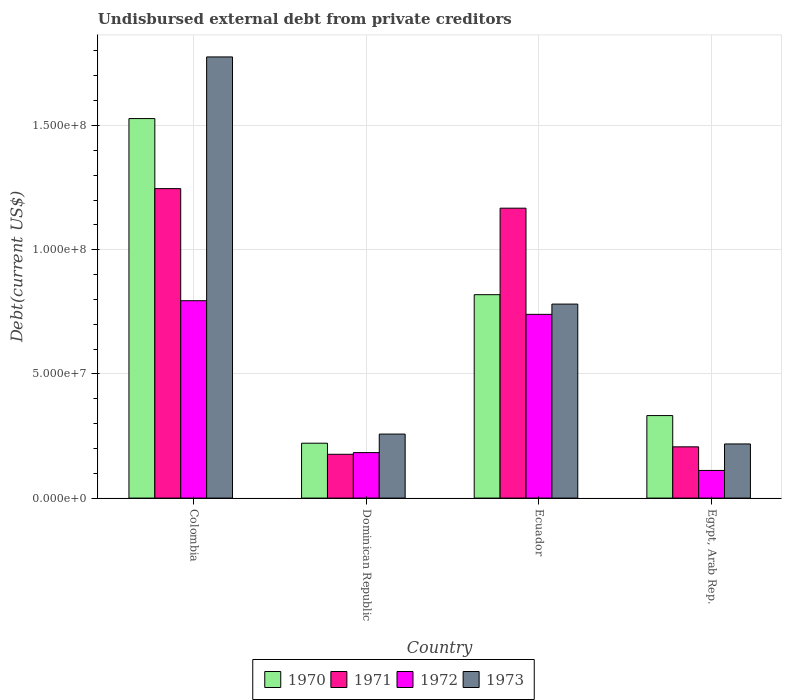How many different coloured bars are there?
Make the answer very short. 4. Are the number of bars per tick equal to the number of legend labels?
Provide a short and direct response. Yes. What is the label of the 3rd group of bars from the left?
Provide a short and direct response. Ecuador. In how many cases, is the number of bars for a given country not equal to the number of legend labels?
Give a very brief answer. 0. What is the total debt in 1970 in Ecuador?
Offer a terse response. 8.19e+07. Across all countries, what is the maximum total debt in 1970?
Provide a short and direct response. 1.53e+08. Across all countries, what is the minimum total debt in 1971?
Ensure brevity in your answer.  1.76e+07. In which country was the total debt in 1971 minimum?
Your response must be concise. Dominican Republic. What is the total total debt in 1971 in the graph?
Keep it short and to the point. 2.80e+08. What is the difference between the total debt in 1971 in Colombia and that in Dominican Republic?
Your answer should be compact. 1.07e+08. What is the difference between the total debt in 1973 in Dominican Republic and the total debt in 1972 in Ecuador?
Provide a short and direct response. -4.82e+07. What is the average total debt in 1972 per country?
Make the answer very short. 4.57e+07. What is the difference between the total debt of/in 1972 and total debt of/in 1970 in Ecuador?
Keep it short and to the point. -7.92e+06. In how many countries, is the total debt in 1973 greater than 20000000 US$?
Offer a terse response. 4. What is the ratio of the total debt in 1972 in Colombia to that in Dominican Republic?
Ensure brevity in your answer.  4.34. What is the difference between the highest and the second highest total debt in 1973?
Offer a very short reply. 9.95e+07. What is the difference between the highest and the lowest total debt in 1972?
Provide a succinct answer. 6.83e+07. What does the 2nd bar from the right in Egypt, Arab Rep. represents?
Offer a terse response. 1972. How many bars are there?
Provide a short and direct response. 16. How many countries are there in the graph?
Give a very brief answer. 4. What is the difference between two consecutive major ticks on the Y-axis?
Offer a terse response. 5.00e+07. Are the values on the major ticks of Y-axis written in scientific E-notation?
Keep it short and to the point. Yes. Where does the legend appear in the graph?
Offer a very short reply. Bottom center. How many legend labels are there?
Keep it short and to the point. 4. What is the title of the graph?
Your answer should be compact. Undisbursed external debt from private creditors. Does "1983" appear as one of the legend labels in the graph?
Provide a short and direct response. No. What is the label or title of the X-axis?
Offer a terse response. Country. What is the label or title of the Y-axis?
Your answer should be compact. Debt(current US$). What is the Debt(current US$) in 1970 in Colombia?
Offer a terse response. 1.53e+08. What is the Debt(current US$) of 1971 in Colombia?
Make the answer very short. 1.25e+08. What is the Debt(current US$) of 1972 in Colombia?
Your answer should be very brief. 7.95e+07. What is the Debt(current US$) of 1973 in Colombia?
Keep it short and to the point. 1.78e+08. What is the Debt(current US$) of 1970 in Dominican Republic?
Provide a succinct answer. 2.21e+07. What is the Debt(current US$) of 1971 in Dominican Republic?
Offer a very short reply. 1.76e+07. What is the Debt(current US$) in 1972 in Dominican Republic?
Your answer should be very brief. 1.83e+07. What is the Debt(current US$) of 1973 in Dominican Republic?
Your answer should be very brief. 2.58e+07. What is the Debt(current US$) in 1970 in Ecuador?
Provide a short and direct response. 8.19e+07. What is the Debt(current US$) in 1971 in Ecuador?
Keep it short and to the point. 1.17e+08. What is the Debt(current US$) of 1972 in Ecuador?
Provide a succinct answer. 7.40e+07. What is the Debt(current US$) of 1973 in Ecuador?
Provide a succinct answer. 7.81e+07. What is the Debt(current US$) in 1970 in Egypt, Arab Rep.?
Offer a terse response. 3.32e+07. What is the Debt(current US$) in 1971 in Egypt, Arab Rep.?
Your answer should be compact. 2.06e+07. What is the Debt(current US$) of 1972 in Egypt, Arab Rep.?
Your answer should be compact. 1.11e+07. What is the Debt(current US$) in 1973 in Egypt, Arab Rep.?
Ensure brevity in your answer.  2.18e+07. Across all countries, what is the maximum Debt(current US$) in 1970?
Offer a very short reply. 1.53e+08. Across all countries, what is the maximum Debt(current US$) in 1971?
Your response must be concise. 1.25e+08. Across all countries, what is the maximum Debt(current US$) of 1972?
Offer a terse response. 7.95e+07. Across all countries, what is the maximum Debt(current US$) of 1973?
Give a very brief answer. 1.78e+08. Across all countries, what is the minimum Debt(current US$) in 1970?
Your answer should be very brief. 2.21e+07. Across all countries, what is the minimum Debt(current US$) in 1971?
Your answer should be compact. 1.76e+07. Across all countries, what is the minimum Debt(current US$) in 1972?
Your response must be concise. 1.11e+07. Across all countries, what is the minimum Debt(current US$) in 1973?
Provide a succinct answer. 2.18e+07. What is the total Debt(current US$) of 1970 in the graph?
Your answer should be compact. 2.90e+08. What is the total Debt(current US$) in 1971 in the graph?
Ensure brevity in your answer.  2.80e+08. What is the total Debt(current US$) of 1972 in the graph?
Offer a terse response. 1.83e+08. What is the total Debt(current US$) in 1973 in the graph?
Your response must be concise. 3.03e+08. What is the difference between the Debt(current US$) in 1970 in Colombia and that in Dominican Republic?
Provide a succinct answer. 1.31e+08. What is the difference between the Debt(current US$) in 1971 in Colombia and that in Dominican Republic?
Offer a terse response. 1.07e+08. What is the difference between the Debt(current US$) of 1972 in Colombia and that in Dominican Republic?
Keep it short and to the point. 6.12e+07. What is the difference between the Debt(current US$) of 1973 in Colombia and that in Dominican Republic?
Ensure brevity in your answer.  1.52e+08. What is the difference between the Debt(current US$) in 1970 in Colombia and that in Ecuador?
Provide a short and direct response. 7.09e+07. What is the difference between the Debt(current US$) in 1971 in Colombia and that in Ecuador?
Provide a succinct answer. 7.88e+06. What is the difference between the Debt(current US$) in 1972 in Colombia and that in Ecuador?
Make the answer very short. 5.49e+06. What is the difference between the Debt(current US$) in 1973 in Colombia and that in Ecuador?
Your answer should be compact. 9.95e+07. What is the difference between the Debt(current US$) in 1970 in Colombia and that in Egypt, Arab Rep.?
Keep it short and to the point. 1.20e+08. What is the difference between the Debt(current US$) in 1971 in Colombia and that in Egypt, Arab Rep.?
Ensure brevity in your answer.  1.04e+08. What is the difference between the Debt(current US$) in 1972 in Colombia and that in Egypt, Arab Rep.?
Ensure brevity in your answer.  6.83e+07. What is the difference between the Debt(current US$) in 1973 in Colombia and that in Egypt, Arab Rep.?
Your response must be concise. 1.56e+08. What is the difference between the Debt(current US$) of 1970 in Dominican Republic and that in Ecuador?
Offer a very short reply. -5.98e+07. What is the difference between the Debt(current US$) of 1971 in Dominican Republic and that in Ecuador?
Keep it short and to the point. -9.91e+07. What is the difference between the Debt(current US$) of 1972 in Dominican Republic and that in Ecuador?
Keep it short and to the point. -5.57e+07. What is the difference between the Debt(current US$) of 1973 in Dominican Republic and that in Ecuador?
Offer a terse response. -5.23e+07. What is the difference between the Debt(current US$) of 1970 in Dominican Republic and that in Egypt, Arab Rep.?
Your answer should be compact. -1.11e+07. What is the difference between the Debt(current US$) in 1971 in Dominican Republic and that in Egypt, Arab Rep.?
Provide a succinct answer. -3.00e+06. What is the difference between the Debt(current US$) in 1972 in Dominican Republic and that in Egypt, Arab Rep.?
Ensure brevity in your answer.  7.19e+06. What is the difference between the Debt(current US$) of 1973 in Dominican Republic and that in Egypt, Arab Rep.?
Keep it short and to the point. 3.97e+06. What is the difference between the Debt(current US$) in 1970 in Ecuador and that in Egypt, Arab Rep.?
Your answer should be very brief. 4.87e+07. What is the difference between the Debt(current US$) of 1971 in Ecuador and that in Egypt, Arab Rep.?
Provide a succinct answer. 9.61e+07. What is the difference between the Debt(current US$) in 1972 in Ecuador and that in Egypt, Arab Rep.?
Provide a succinct answer. 6.28e+07. What is the difference between the Debt(current US$) in 1973 in Ecuador and that in Egypt, Arab Rep.?
Provide a succinct answer. 5.63e+07. What is the difference between the Debt(current US$) of 1970 in Colombia and the Debt(current US$) of 1971 in Dominican Republic?
Provide a succinct answer. 1.35e+08. What is the difference between the Debt(current US$) in 1970 in Colombia and the Debt(current US$) in 1972 in Dominican Republic?
Your response must be concise. 1.34e+08. What is the difference between the Debt(current US$) in 1970 in Colombia and the Debt(current US$) in 1973 in Dominican Republic?
Your answer should be very brief. 1.27e+08. What is the difference between the Debt(current US$) in 1971 in Colombia and the Debt(current US$) in 1972 in Dominican Republic?
Your response must be concise. 1.06e+08. What is the difference between the Debt(current US$) of 1971 in Colombia and the Debt(current US$) of 1973 in Dominican Republic?
Ensure brevity in your answer.  9.88e+07. What is the difference between the Debt(current US$) in 1972 in Colombia and the Debt(current US$) in 1973 in Dominican Republic?
Provide a short and direct response. 5.37e+07. What is the difference between the Debt(current US$) in 1970 in Colombia and the Debt(current US$) in 1971 in Ecuador?
Make the answer very short. 3.61e+07. What is the difference between the Debt(current US$) in 1970 in Colombia and the Debt(current US$) in 1972 in Ecuador?
Provide a succinct answer. 7.88e+07. What is the difference between the Debt(current US$) in 1970 in Colombia and the Debt(current US$) in 1973 in Ecuador?
Offer a terse response. 7.47e+07. What is the difference between the Debt(current US$) in 1971 in Colombia and the Debt(current US$) in 1972 in Ecuador?
Provide a succinct answer. 5.06e+07. What is the difference between the Debt(current US$) of 1971 in Colombia and the Debt(current US$) of 1973 in Ecuador?
Offer a terse response. 4.65e+07. What is the difference between the Debt(current US$) of 1972 in Colombia and the Debt(current US$) of 1973 in Ecuador?
Your answer should be compact. 1.36e+06. What is the difference between the Debt(current US$) in 1970 in Colombia and the Debt(current US$) in 1971 in Egypt, Arab Rep.?
Give a very brief answer. 1.32e+08. What is the difference between the Debt(current US$) in 1970 in Colombia and the Debt(current US$) in 1972 in Egypt, Arab Rep.?
Offer a very short reply. 1.42e+08. What is the difference between the Debt(current US$) of 1970 in Colombia and the Debt(current US$) of 1973 in Egypt, Arab Rep.?
Provide a succinct answer. 1.31e+08. What is the difference between the Debt(current US$) of 1971 in Colombia and the Debt(current US$) of 1972 in Egypt, Arab Rep.?
Ensure brevity in your answer.  1.13e+08. What is the difference between the Debt(current US$) in 1971 in Colombia and the Debt(current US$) in 1973 in Egypt, Arab Rep.?
Provide a succinct answer. 1.03e+08. What is the difference between the Debt(current US$) in 1972 in Colombia and the Debt(current US$) in 1973 in Egypt, Arab Rep.?
Give a very brief answer. 5.77e+07. What is the difference between the Debt(current US$) in 1970 in Dominican Republic and the Debt(current US$) in 1971 in Ecuador?
Ensure brevity in your answer.  -9.46e+07. What is the difference between the Debt(current US$) in 1970 in Dominican Republic and the Debt(current US$) in 1972 in Ecuador?
Ensure brevity in your answer.  -5.19e+07. What is the difference between the Debt(current US$) in 1970 in Dominican Republic and the Debt(current US$) in 1973 in Ecuador?
Make the answer very short. -5.60e+07. What is the difference between the Debt(current US$) in 1971 in Dominican Republic and the Debt(current US$) in 1972 in Ecuador?
Your response must be concise. -5.63e+07. What is the difference between the Debt(current US$) of 1971 in Dominican Republic and the Debt(current US$) of 1973 in Ecuador?
Keep it short and to the point. -6.05e+07. What is the difference between the Debt(current US$) in 1972 in Dominican Republic and the Debt(current US$) in 1973 in Ecuador?
Make the answer very short. -5.98e+07. What is the difference between the Debt(current US$) of 1970 in Dominican Republic and the Debt(current US$) of 1971 in Egypt, Arab Rep.?
Your response must be concise. 1.46e+06. What is the difference between the Debt(current US$) of 1970 in Dominican Republic and the Debt(current US$) of 1972 in Egypt, Arab Rep.?
Offer a terse response. 1.10e+07. What is the difference between the Debt(current US$) in 1970 in Dominican Republic and the Debt(current US$) in 1973 in Egypt, Arab Rep.?
Your answer should be very brief. 2.96e+05. What is the difference between the Debt(current US$) in 1971 in Dominican Republic and the Debt(current US$) in 1972 in Egypt, Arab Rep.?
Your answer should be compact. 6.50e+06. What is the difference between the Debt(current US$) in 1971 in Dominican Republic and the Debt(current US$) in 1973 in Egypt, Arab Rep.?
Offer a very short reply. -4.17e+06. What is the difference between the Debt(current US$) of 1972 in Dominican Republic and the Debt(current US$) of 1973 in Egypt, Arab Rep.?
Offer a very short reply. -3.48e+06. What is the difference between the Debt(current US$) of 1970 in Ecuador and the Debt(current US$) of 1971 in Egypt, Arab Rep.?
Offer a very short reply. 6.13e+07. What is the difference between the Debt(current US$) in 1970 in Ecuador and the Debt(current US$) in 1972 in Egypt, Arab Rep.?
Offer a very short reply. 7.08e+07. What is the difference between the Debt(current US$) of 1970 in Ecuador and the Debt(current US$) of 1973 in Egypt, Arab Rep.?
Make the answer very short. 6.01e+07. What is the difference between the Debt(current US$) of 1971 in Ecuador and the Debt(current US$) of 1972 in Egypt, Arab Rep.?
Provide a succinct answer. 1.06e+08. What is the difference between the Debt(current US$) of 1971 in Ecuador and the Debt(current US$) of 1973 in Egypt, Arab Rep.?
Provide a succinct answer. 9.49e+07. What is the difference between the Debt(current US$) in 1972 in Ecuador and the Debt(current US$) in 1973 in Egypt, Arab Rep.?
Your answer should be very brief. 5.22e+07. What is the average Debt(current US$) of 1970 per country?
Keep it short and to the point. 7.25e+07. What is the average Debt(current US$) in 1971 per country?
Your answer should be very brief. 6.99e+07. What is the average Debt(current US$) in 1972 per country?
Give a very brief answer. 4.57e+07. What is the average Debt(current US$) of 1973 per country?
Keep it short and to the point. 7.58e+07. What is the difference between the Debt(current US$) in 1970 and Debt(current US$) in 1971 in Colombia?
Your response must be concise. 2.82e+07. What is the difference between the Debt(current US$) in 1970 and Debt(current US$) in 1972 in Colombia?
Make the answer very short. 7.33e+07. What is the difference between the Debt(current US$) of 1970 and Debt(current US$) of 1973 in Colombia?
Ensure brevity in your answer.  -2.48e+07. What is the difference between the Debt(current US$) in 1971 and Debt(current US$) in 1972 in Colombia?
Provide a succinct answer. 4.51e+07. What is the difference between the Debt(current US$) in 1971 and Debt(current US$) in 1973 in Colombia?
Your answer should be compact. -5.30e+07. What is the difference between the Debt(current US$) of 1972 and Debt(current US$) of 1973 in Colombia?
Your answer should be compact. -9.81e+07. What is the difference between the Debt(current US$) of 1970 and Debt(current US$) of 1971 in Dominican Republic?
Offer a terse response. 4.46e+06. What is the difference between the Debt(current US$) in 1970 and Debt(current US$) in 1972 in Dominican Republic?
Offer a very short reply. 3.78e+06. What is the difference between the Debt(current US$) of 1970 and Debt(current US$) of 1973 in Dominican Republic?
Give a very brief answer. -3.68e+06. What is the difference between the Debt(current US$) in 1971 and Debt(current US$) in 1972 in Dominican Republic?
Provide a short and direct response. -6.84e+05. What is the difference between the Debt(current US$) in 1971 and Debt(current US$) in 1973 in Dominican Republic?
Provide a short and direct response. -8.14e+06. What is the difference between the Debt(current US$) in 1972 and Debt(current US$) in 1973 in Dominican Republic?
Keep it short and to the point. -7.46e+06. What is the difference between the Debt(current US$) of 1970 and Debt(current US$) of 1971 in Ecuador?
Keep it short and to the point. -3.48e+07. What is the difference between the Debt(current US$) in 1970 and Debt(current US$) in 1972 in Ecuador?
Keep it short and to the point. 7.92e+06. What is the difference between the Debt(current US$) in 1970 and Debt(current US$) in 1973 in Ecuador?
Provide a short and direct response. 3.78e+06. What is the difference between the Debt(current US$) of 1971 and Debt(current US$) of 1972 in Ecuador?
Keep it short and to the point. 4.27e+07. What is the difference between the Debt(current US$) of 1971 and Debt(current US$) of 1973 in Ecuador?
Your answer should be compact. 3.86e+07. What is the difference between the Debt(current US$) in 1972 and Debt(current US$) in 1973 in Ecuador?
Offer a terse response. -4.14e+06. What is the difference between the Debt(current US$) of 1970 and Debt(current US$) of 1971 in Egypt, Arab Rep.?
Make the answer very short. 1.26e+07. What is the difference between the Debt(current US$) in 1970 and Debt(current US$) in 1972 in Egypt, Arab Rep.?
Your answer should be compact. 2.21e+07. What is the difference between the Debt(current US$) in 1970 and Debt(current US$) in 1973 in Egypt, Arab Rep.?
Offer a very short reply. 1.14e+07. What is the difference between the Debt(current US$) in 1971 and Debt(current US$) in 1972 in Egypt, Arab Rep.?
Give a very brief answer. 9.50e+06. What is the difference between the Debt(current US$) in 1971 and Debt(current US$) in 1973 in Egypt, Arab Rep.?
Ensure brevity in your answer.  -1.17e+06. What is the difference between the Debt(current US$) of 1972 and Debt(current US$) of 1973 in Egypt, Arab Rep.?
Ensure brevity in your answer.  -1.07e+07. What is the ratio of the Debt(current US$) of 1970 in Colombia to that in Dominican Republic?
Your response must be concise. 6.92. What is the ratio of the Debt(current US$) in 1971 in Colombia to that in Dominican Republic?
Ensure brevity in your answer.  7.07. What is the ratio of the Debt(current US$) in 1972 in Colombia to that in Dominican Republic?
Your answer should be very brief. 4.34. What is the ratio of the Debt(current US$) of 1973 in Colombia to that in Dominican Republic?
Keep it short and to the point. 6.89. What is the ratio of the Debt(current US$) in 1970 in Colombia to that in Ecuador?
Your answer should be very brief. 1.87. What is the ratio of the Debt(current US$) of 1971 in Colombia to that in Ecuador?
Offer a terse response. 1.07. What is the ratio of the Debt(current US$) in 1972 in Colombia to that in Ecuador?
Keep it short and to the point. 1.07. What is the ratio of the Debt(current US$) of 1973 in Colombia to that in Ecuador?
Provide a short and direct response. 2.27. What is the ratio of the Debt(current US$) of 1970 in Colombia to that in Egypt, Arab Rep.?
Your answer should be compact. 4.6. What is the ratio of the Debt(current US$) of 1971 in Colombia to that in Egypt, Arab Rep.?
Give a very brief answer. 6.04. What is the ratio of the Debt(current US$) in 1972 in Colombia to that in Egypt, Arab Rep.?
Your response must be concise. 7.14. What is the ratio of the Debt(current US$) of 1973 in Colombia to that in Egypt, Arab Rep.?
Provide a succinct answer. 8.15. What is the ratio of the Debt(current US$) of 1970 in Dominican Republic to that in Ecuador?
Make the answer very short. 0.27. What is the ratio of the Debt(current US$) in 1971 in Dominican Republic to that in Ecuador?
Offer a very short reply. 0.15. What is the ratio of the Debt(current US$) of 1972 in Dominican Republic to that in Ecuador?
Offer a very short reply. 0.25. What is the ratio of the Debt(current US$) of 1973 in Dominican Republic to that in Ecuador?
Provide a short and direct response. 0.33. What is the ratio of the Debt(current US$) in 1970 in Dominican Republic to that in Egypt, Arab Rep.?
Offer a terse response. 0.67. What is the ratio of the Debt(current US$) in 1971 in Dominican Republic to that in Egypt, Arab Rep.?
Offer a terse response. 0.85. What is the ratio of the Debt(current US$) of 1972 in Dominican Republic to that in Egypt, Arab Rep.?
Ensure brevity in your answer.  1.65. What is the ratio of the Debt(current US$) of 1973 in Dominican Republic to that in Egypt, Arab Rep.?
Ensure brevity in your answer.  1.18. What is the ratio of the Debt(current US$) in 1970 in Ecuador to that in Egypt, Arab Rep.?
Offer a terse response. 2.47. What is the ratio of the Debt(current US$) of 1971 in Ecuador to that in Egypt, Arab Rep.?
Offer a very short reply. 5.66. What is the ratio of the Debt(current US$) of 1972 in Ecuador to that in Egypt, Arab Rep.?
Your response must be concise. 6.65. What is the ratio of the Debt(current US$) in 1973 in Ecuador to that in Egypt, Arab Rep.?
Your answer should be very brief. 3.58. What is the difference between the highest and the second highest Debt(current US$) of 1970?
Give a very brief answer. 7.09e+07. What is the difference between the highest and the second highest Debt(current US$) of 1971?
Your answer should be compact. 7.88e+06. What is the difference between the highest and the second highest Debt(current US$) in 1972?
Offer a terse response. 5.49e+06. What is the difference between the highest and the second highest Debt(current US$) of 1973?
Keep it short and to the point. 9.95e+07. What is the difference between the highest and the lowest Debt(current US$) of 1970?
Your answer should be very brief. 1.31e+08. What is the difference between the highest and the lowest Debt(current US$) in 1971?
Your answer should be very brief. 1.07e+08. What is the difference between the highest and the lowest Debt(current US$) of 1972?
Your answer should be compact. 6.83e+07. What is the difference between the highest and the lowest Debt(current US$) in 1973?
Offer a very short reply. 1.56e+08. 